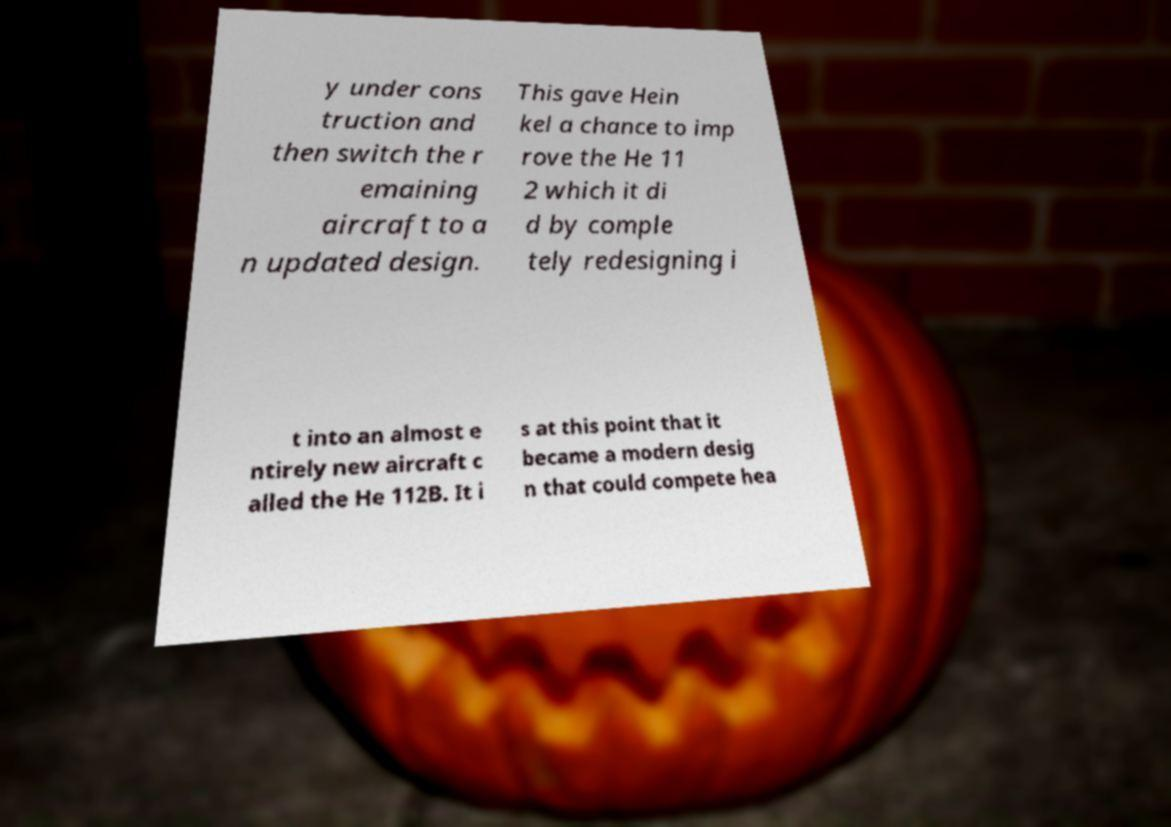What messages or text are displayed in this image? I need them in a readable, typed format. y under cons truction and then switch the r emaining aircraft to a n updated design. This gave Hein kel a chance to imp rove the He 11 2 which it di d by comple tely redesigning i t into an almost e ntirely new aircraft c alled the He 112B. It i s at this point that it became a modern desig n that could compete hea 